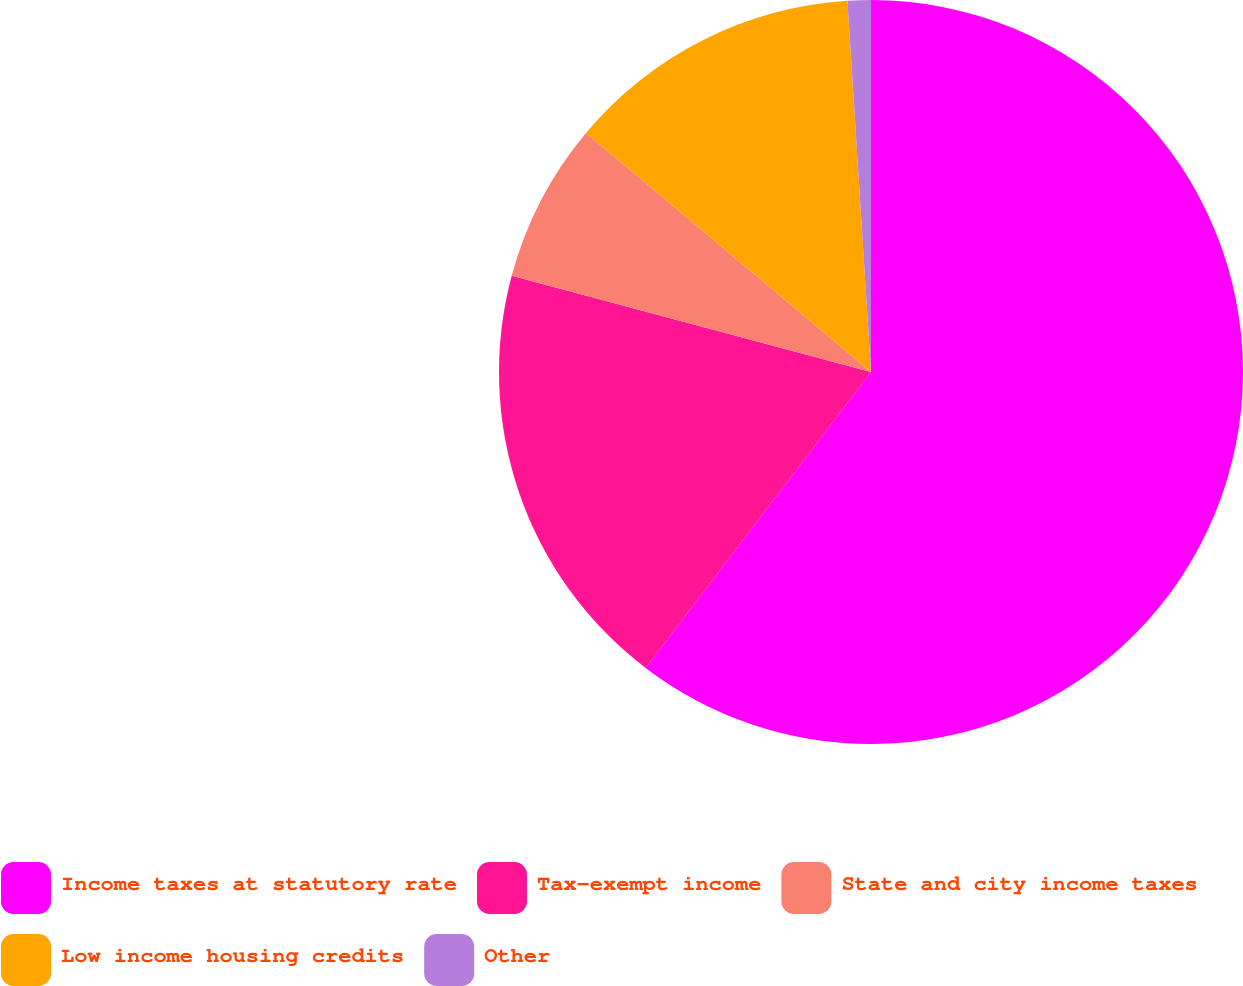<chart> <loc_0><loc_0><loc_500><loc_500><pie_chart><fcel>Income taxes at statutory rate<fcel>Tax-exempt income<fcel>State and city income taxes<fcel>Low income housing credits<fcel>Other<nl><fcel>60.36%<fcel>18.81%<fcel>6.94%<fcel>12.88%<fcel>1.01%<nl></chart> 